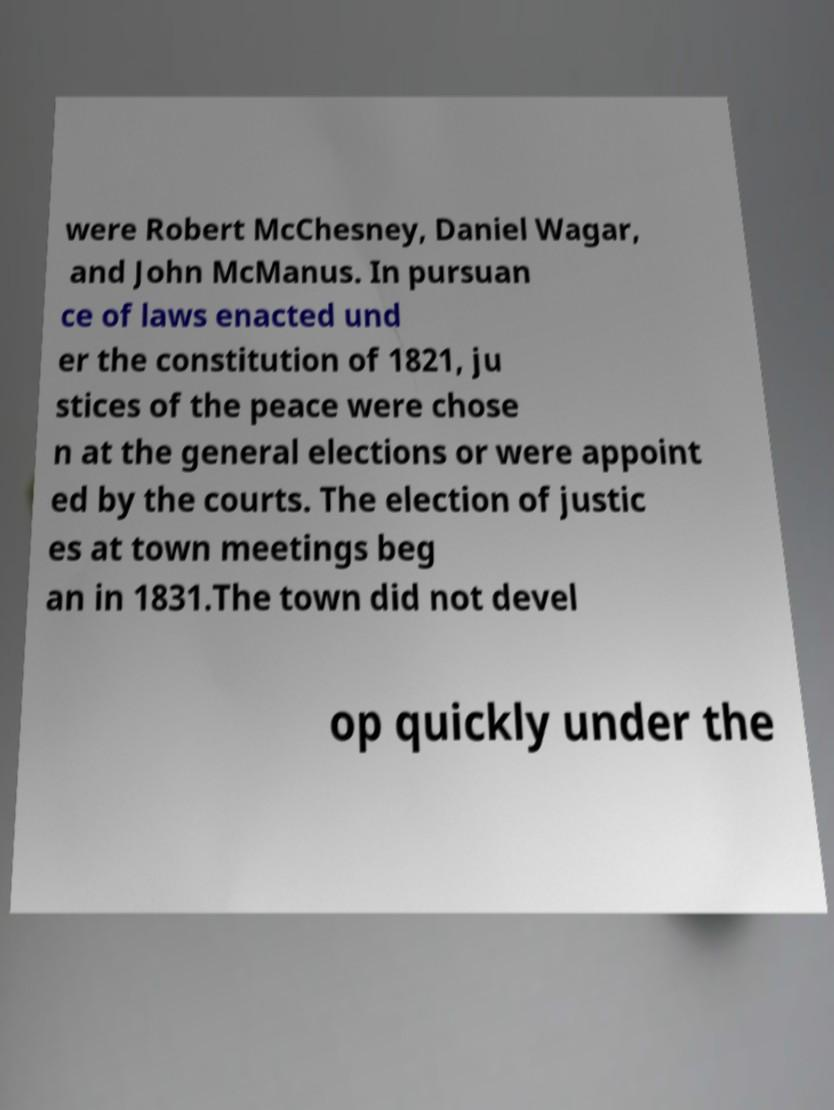For documentation purposes, I need the text within this image transcribed. Could you provide that? were Robert McChesney, Daniel Wagar, and John McManus. In pursuan ce of laws enacted und er the constitution of 1821, ju stices of the peace were chose n at the general elections or were appoint ed by the courts. The election of justic es at town meetings beg an in 1831.The town did not devel op quickly under the 